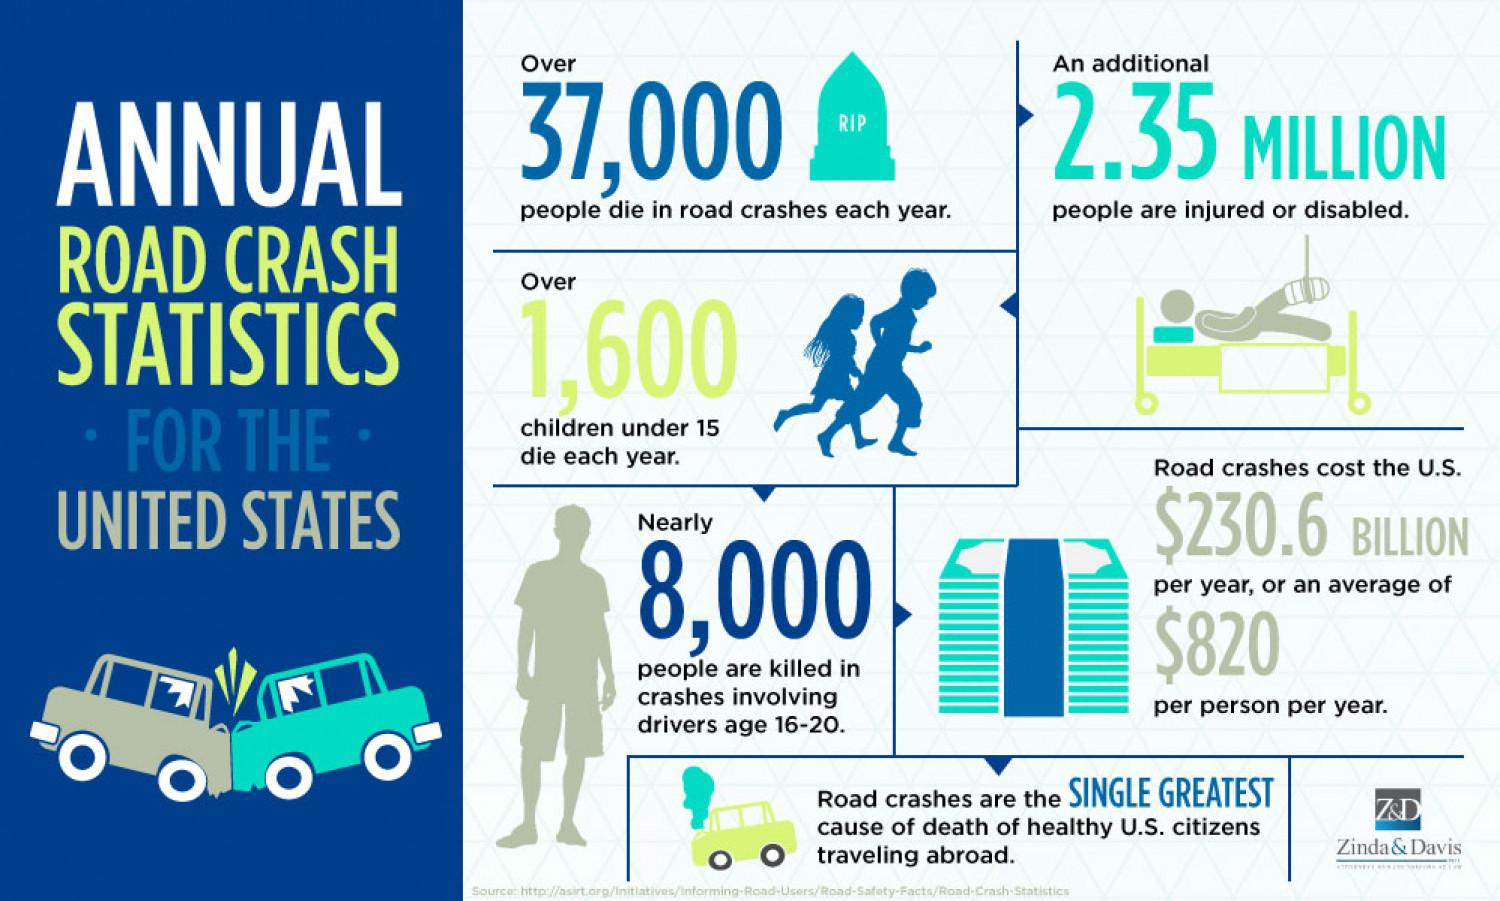List a handful of essential elements in this visual. According to statistics, the age group of drivers that are mainly killed in annual road crashes are those between 16 and 20 years old. In the United States, the average cost of a road crash per person per year is estimated to be $820. Approximately 2.35 million people in the United States are injured or disabled as a result of road crashes every year. Road crashes are the major cause of death that contributes to the healthy citizens of the United States traveling abroad. Approximately 37,000 people lose their lives in road crashes annually in the United States, according to recent statistics. 